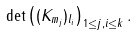<formula> <loc_0><loc_0><loc_500><loc_500>\det \left ( ( K _ { m _ { j } } ) _ { l _ { i } } \right ) _ { 1 \leq j , i \leq k } .</formula> 